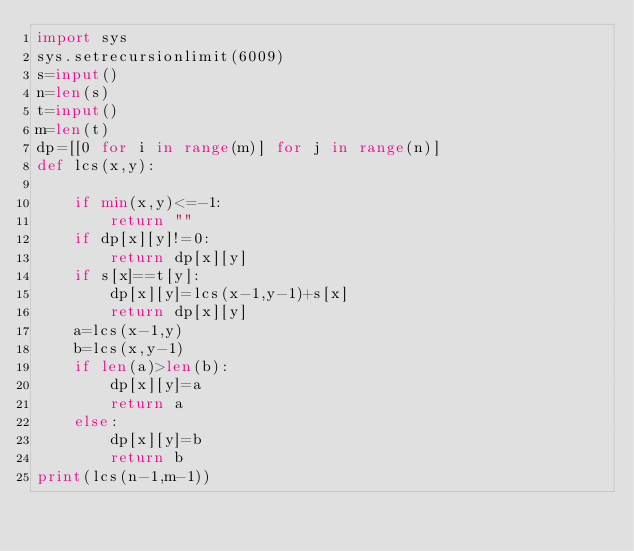Convert code to text. <code><loc_0><loc_0><loc_500><loc_500><_Python_>import sys
sys.setrecursionlimit(6009)
s=input()
n=len(s)
t=input()
m=len(t)
dp=[[0 for i in range(m)] for j in range(n)]
def lcs(x,y):
	
	if min(x,y)<=-1:
		return ""
	if dp[x][y]!=0:
		return dp[x][y]
	if s[x]==t[y]:
		dp[x][y]=lcs(x-1,y-1)+s[x]
		return dp[x][y]
	a=lcs(x-1,y)
	b=lcs(x,y-1)
	if len(a)>len(b):
		dp[x][y]=a
		return a
	else:
		dp[x][y]=b
		return b
print(lcs(n-1,m-1))</code> 